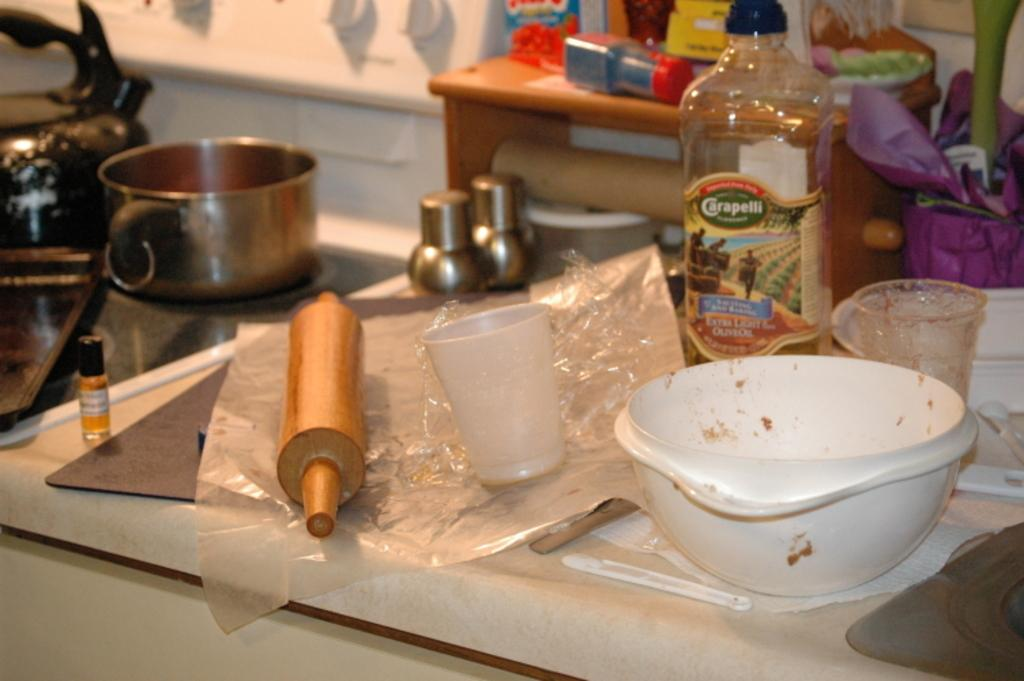What type of items can be seen in the image? There are many utensils in the image. What is the surface on which these items are placed? There are objects placed on the table. Is there any greenery visible in the image? Yes, there is a plant at the right side of the image. Can you see a stone statue of a porter carrying a suitcase in the image? No, there is no stone statue or porter carrying a suitcase in the image. 